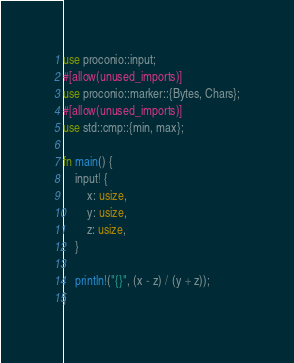Convert code to text. <code><loc_0><loc_0><loc_500><loc_500><_Rust_>use proconio::input;
#[allow(unused_imports)]
use proconio::marker::{Bytes, Chars};
#[allow(unused_imports)]
use std::cmp::{min, max};

fn main() {
	input! {
		x: usize,
		y: usize,
		z: usize,
	}

	println!("{}", (x - z) / (y + z));
}

</code> 